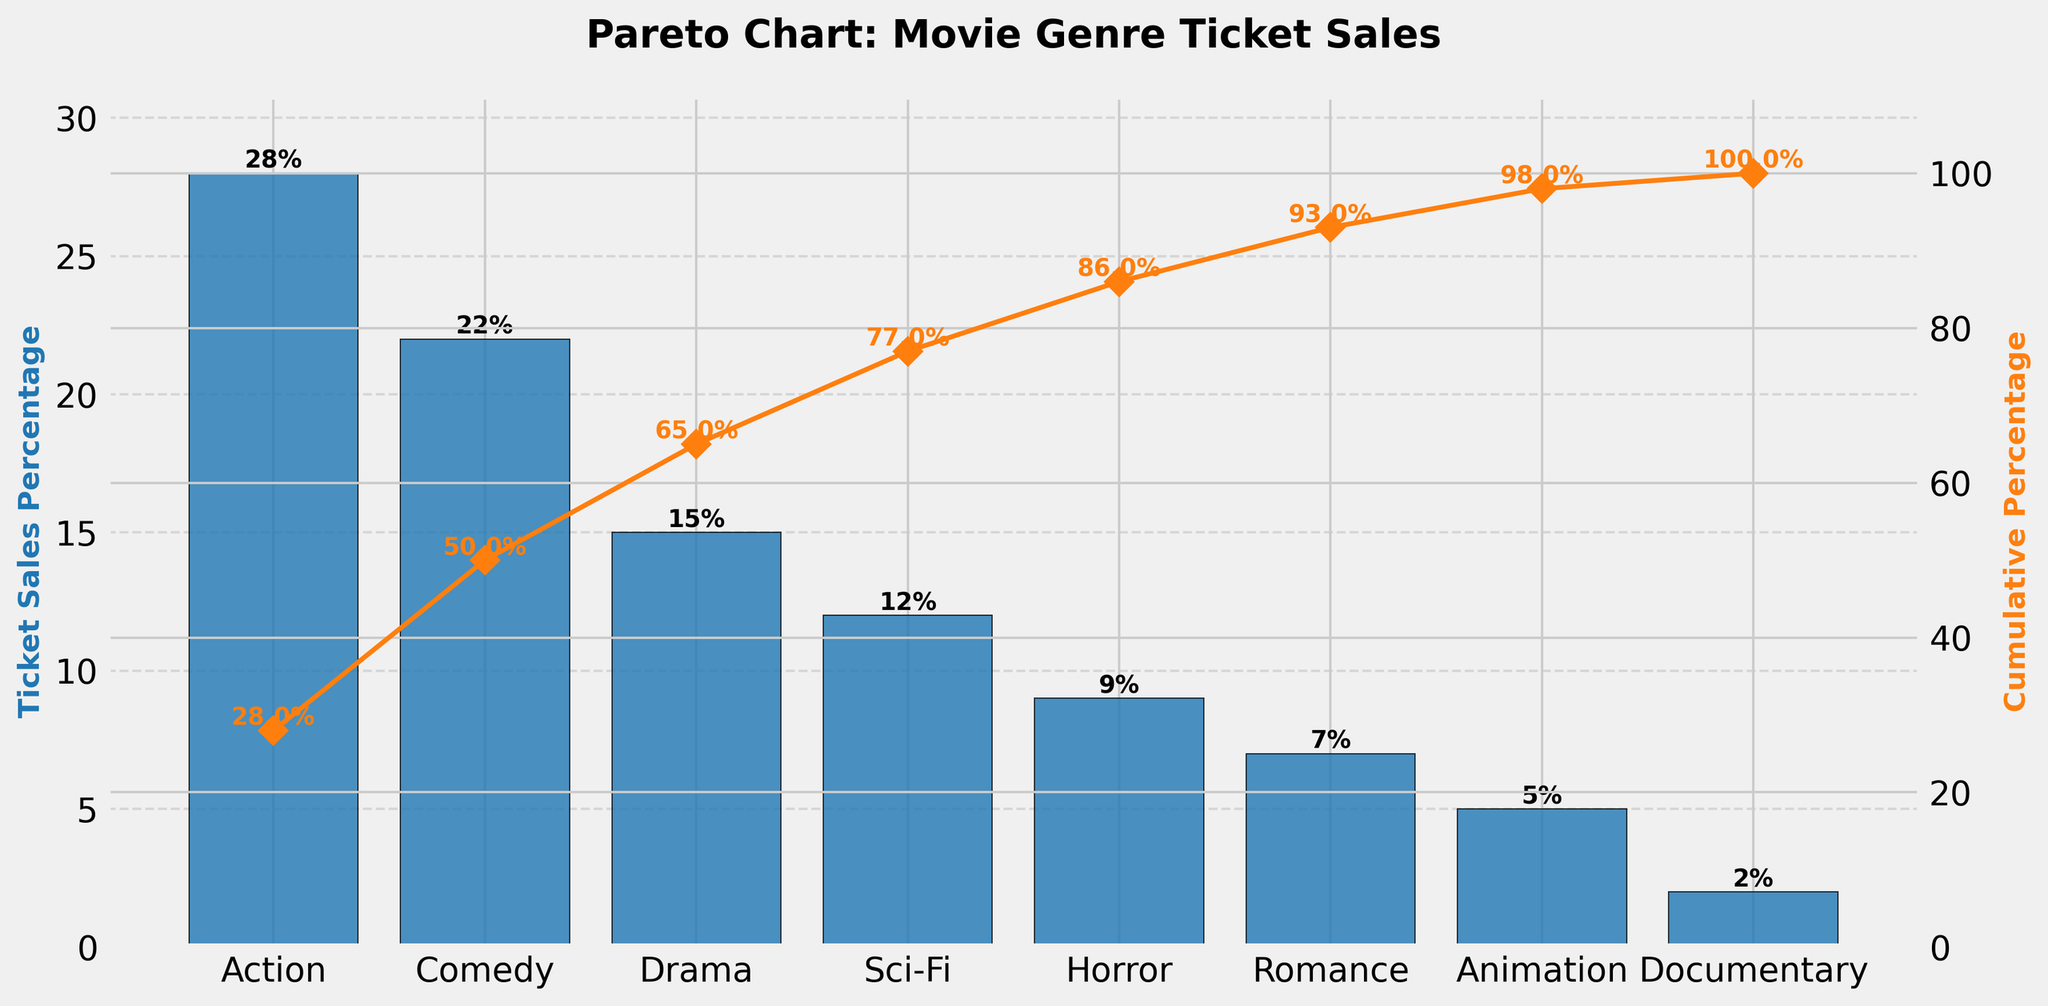What is the title of the chart? The title of the chart is the text displayed at the top of the figure that provides a brief description of the plot
Answer: Pareto Chart: Movie Genre Ticket Sales Which genre has the highest ticket sales percentage? The genre with the highest bar in the chart represents the highest ticket sales percentage, and it is typically labeled on the x-axis beneath the bar
Answer: Action How many genres have ticket sales percentages greater than 10%? Count the number of bars that exceed the 10% mark on the y-axis
Answer: Four (Action, Comedy, Drama, Sci-Fi) What is the cumulative percentage after including Sci-Fi? The cumulative percentage line and labels on the plot show the accumulation of percentages up to each genre. Locate the point above Sci-Fi on the orange line
Answer: 77% Which genre contributes the least to ticket sales? The genre with the shortest bar on the chart represents the least ticket sales percentage
Answer: Documentary What is the total ticket sales percentage of the top three genres? Add the percentages of the top three genres displayed in the chart (Action, Comedy, Drama)
Answer: 28% + 22% + 15% = 65% By how much does the ticket sales percentage of Action exceed that of Horror? Subtract the percentage of Horror from the percentage of Action to find the difference
Answer: 28% - 9% = 19% Which genres, when combined, contribute more than 50% to ticket sales? Sum the percentages starting from the highest until the total exceeds 50%, noting the corresponding genres
Answer: Action and Comedy (28% + 22% = 50%) Does the cumulative percentage ever reach 100%? The cumulative percentage line plotted on the chart indicates whether or not it reaches 100%. Check the plot labels or the line’s endpoint
Answer: No, it goes up to 100% with the final genre Which genre shows just below a 20% increase in cumulative percentage? Locate the cumulative percentage plot line and find the point where the increase from the previous genre is just below 20%
Answer: Comedy (adds 22% to Action's 28%, totaling 50%) 